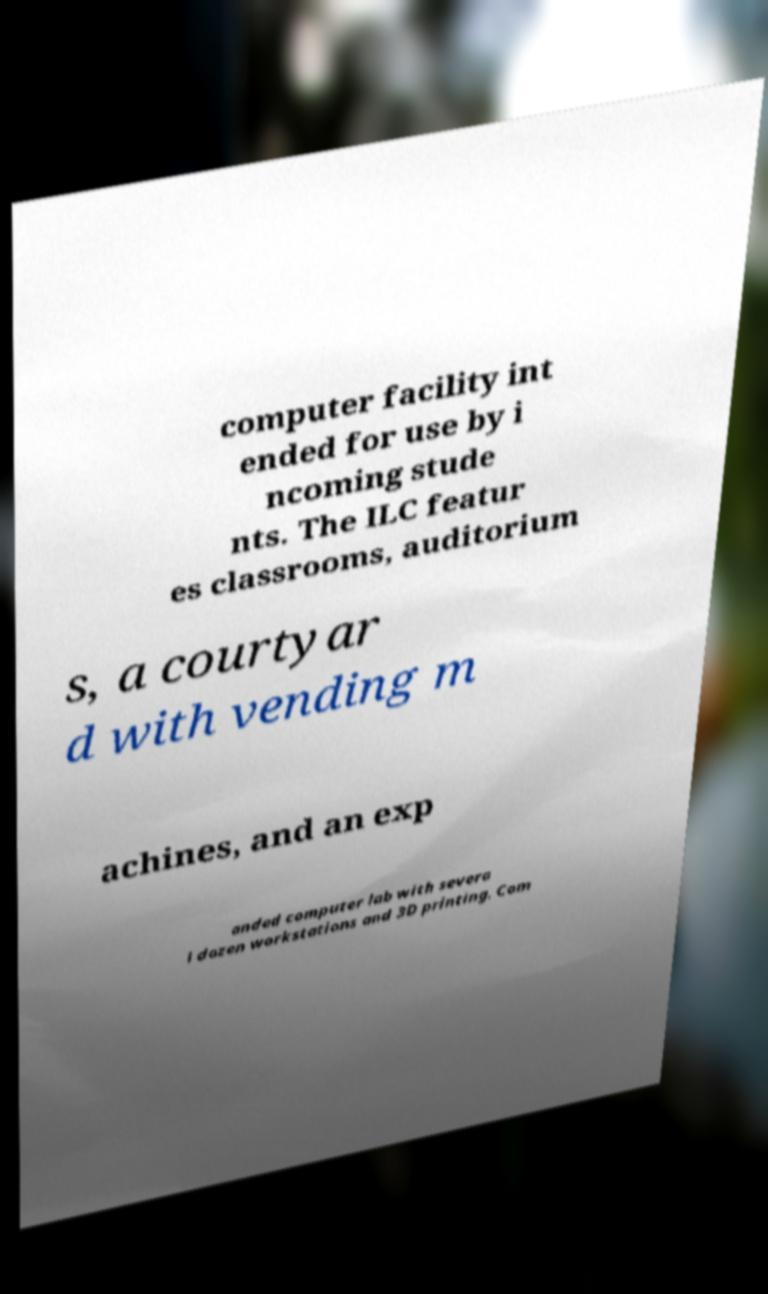There's text embedded in this image that I need extracted. Can you transcribe it verbatim? computer facility int ended for use by i ncoming stude nts. The ILC featur es classrooms, auditorium s, a courtyar d with vending m achines, and an exp anded computer lab with severa l dozen workstations and 3D printing. Com 